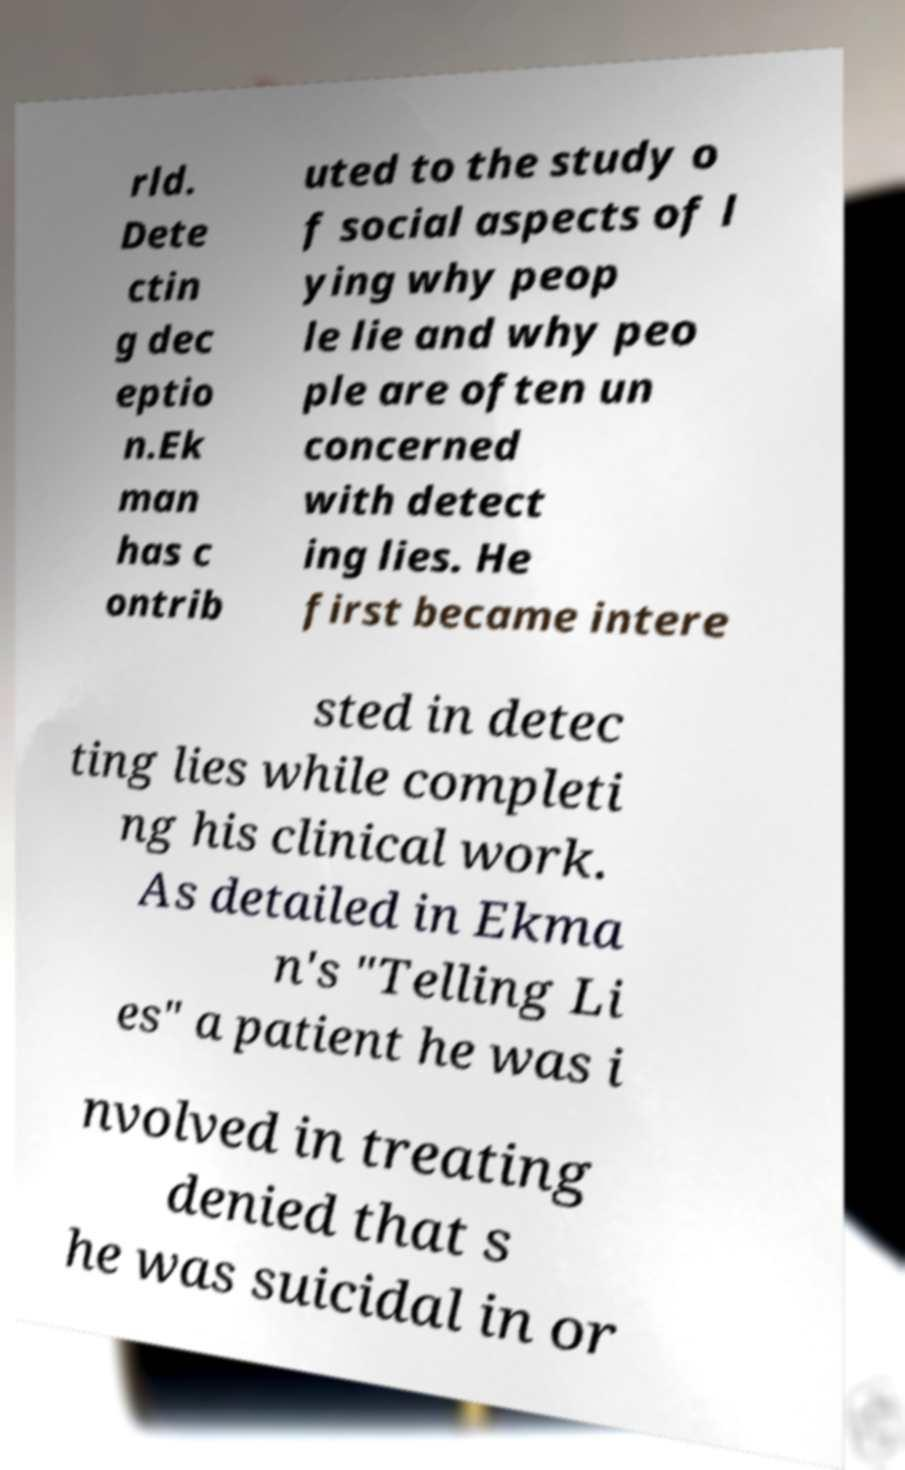Can you read and provide the text displayed in the image?This photo seems to have some interesting text. Can you extract and type it out for me? rld. Dete ctin g dec eptio n.Ek man has c ontrib uted to the study o f social aspects of l ying why peop le lie and why peo ple are often un concerned with detect ing lies. He first became intere sted in detec ting lies while completi ng his clinical work. As detailed in Ekma n's "Telling Li es" a patient he was i nvolved in treating denied that s he was suicidal in or 